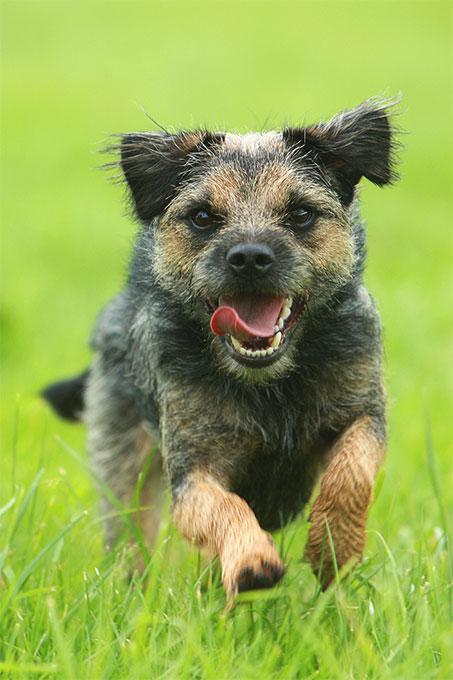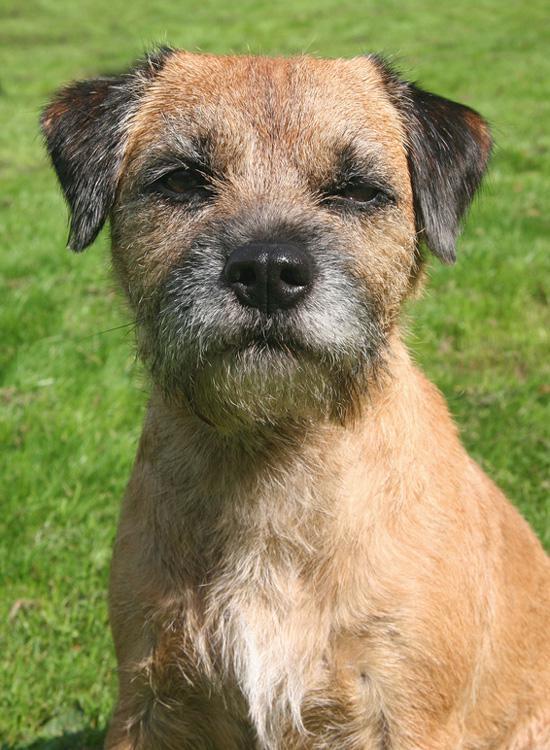The first image is the image on the left, the second image is the image on the right. For the images displayed, is the sentence "A dog is looking directly at the camera in both images." factually correct? Answer yes or no. Yes. 